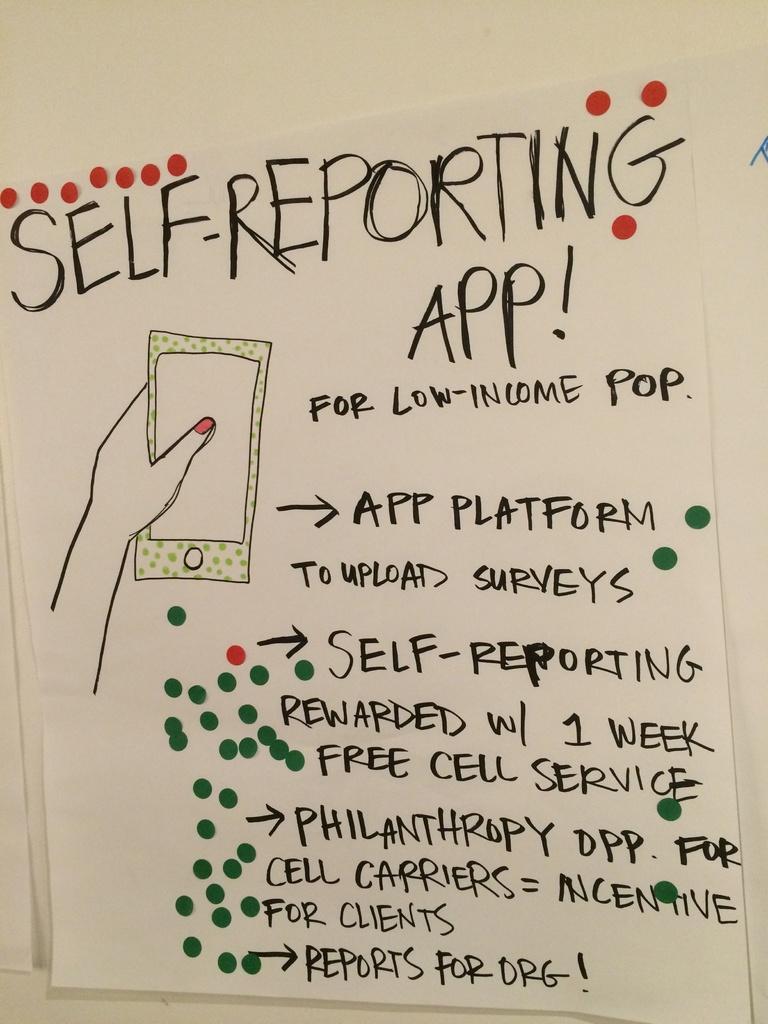How would you summarize this image in a sentence or two? This image consists of a paper pasted on the wall. On which there is a picture of a cell phone and there is a text. The wall is in white color. 